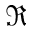<formula> <loc_0><loc_0><loc_500><loc_500>\Re</formula> 